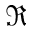<formula> <loc_0><loc_0><loc_500><loc_500>\Re</formula> 